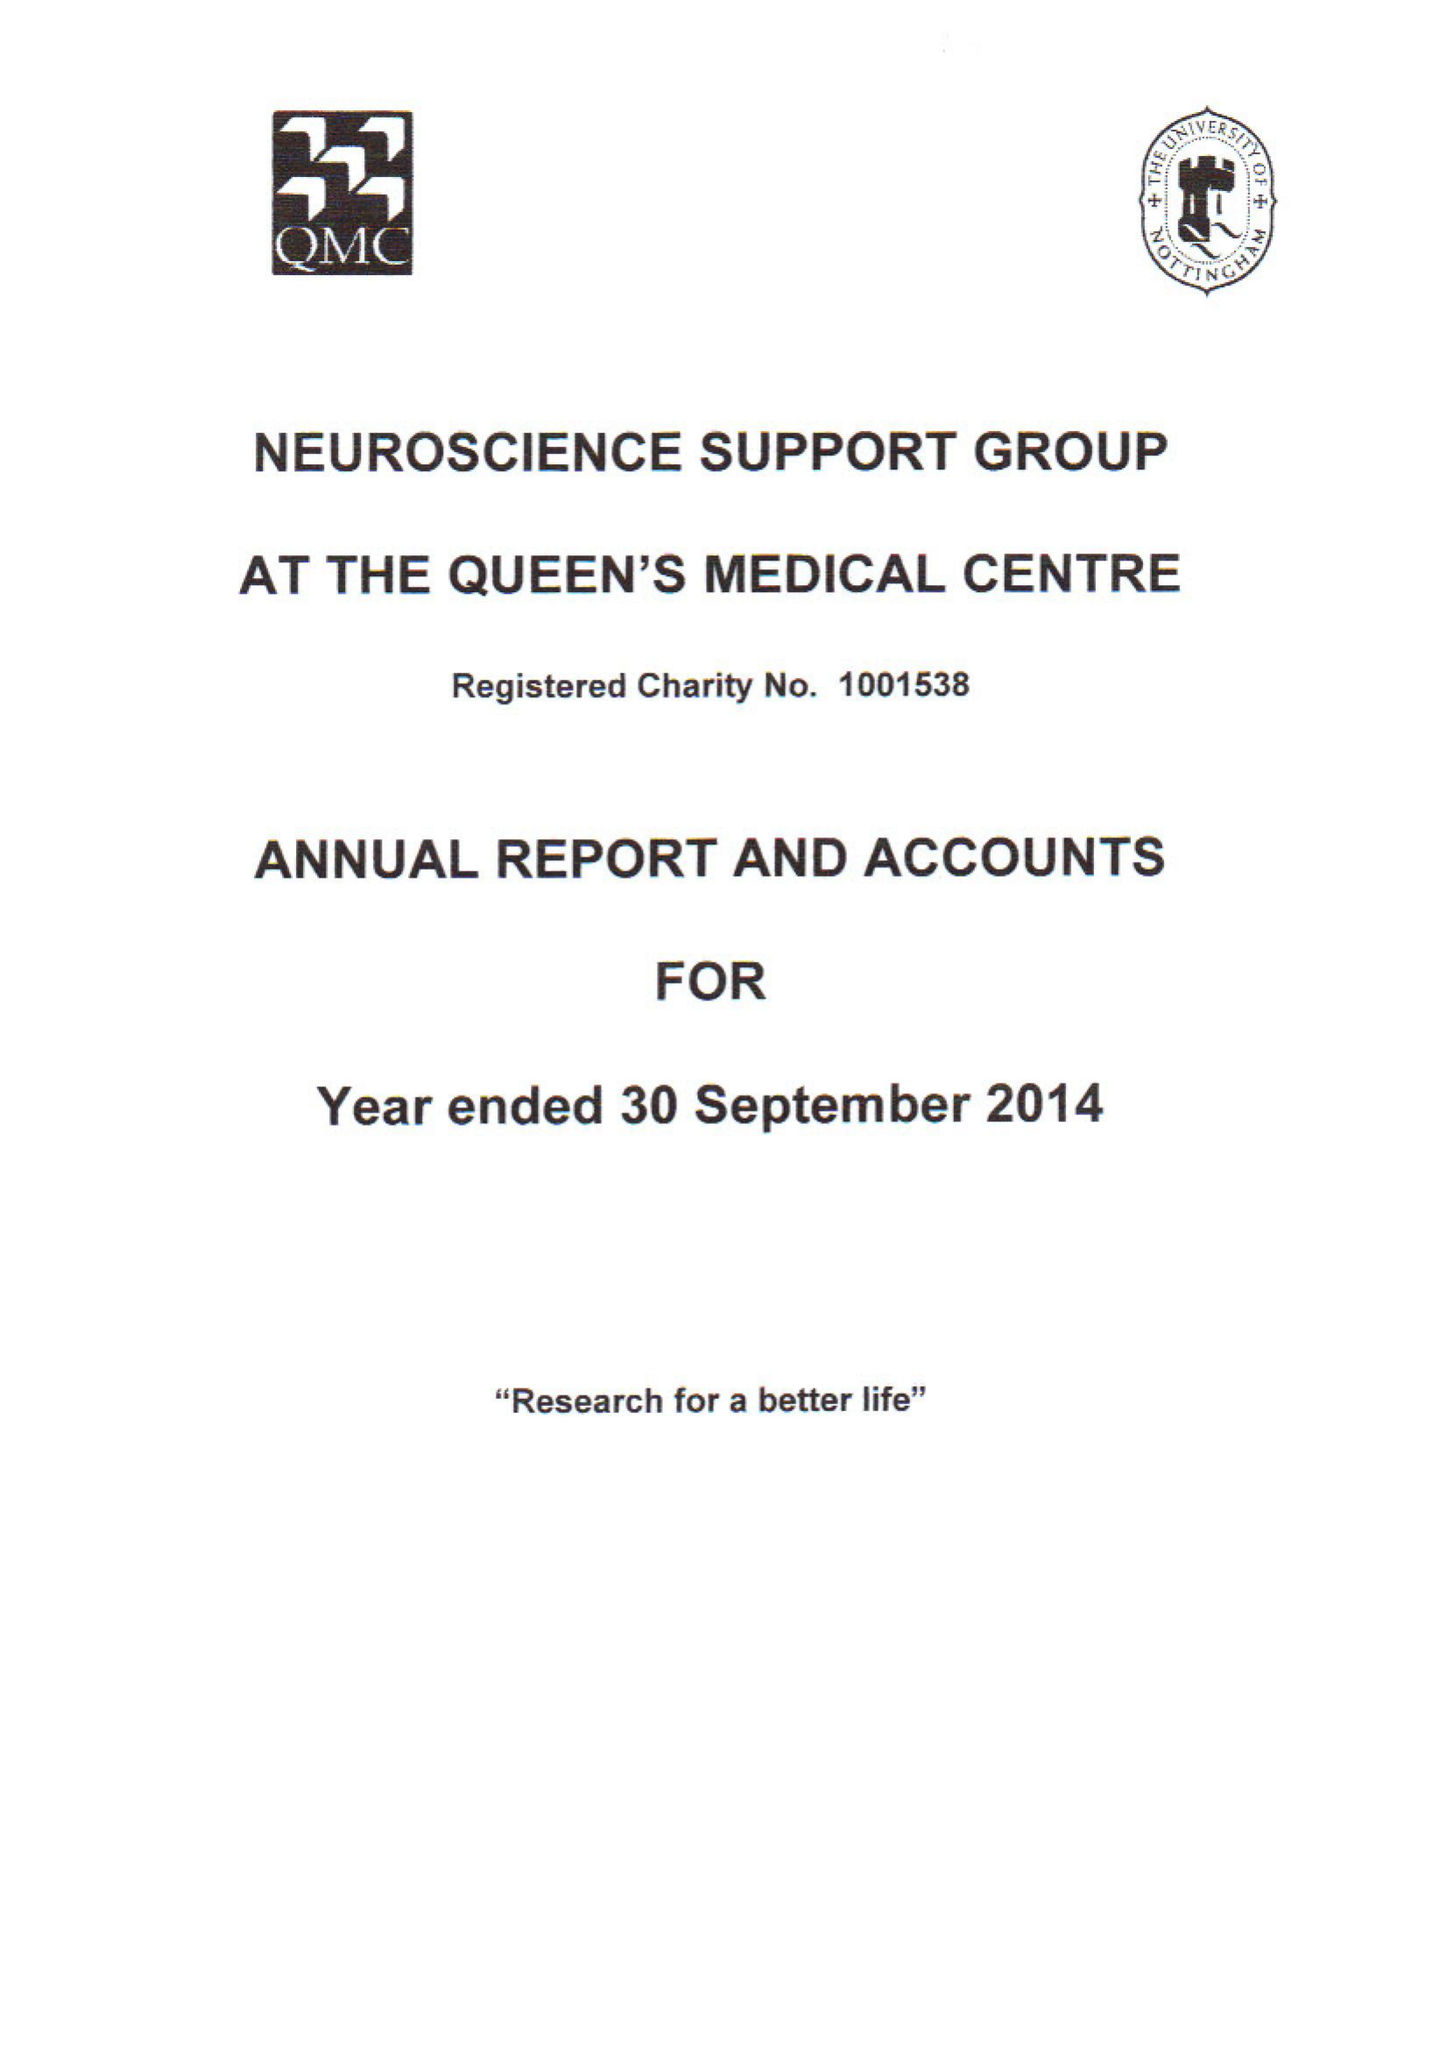What is the value for the income_annually_in_british_pounds?
Answer the question using a single word or phrase. 56251.00 